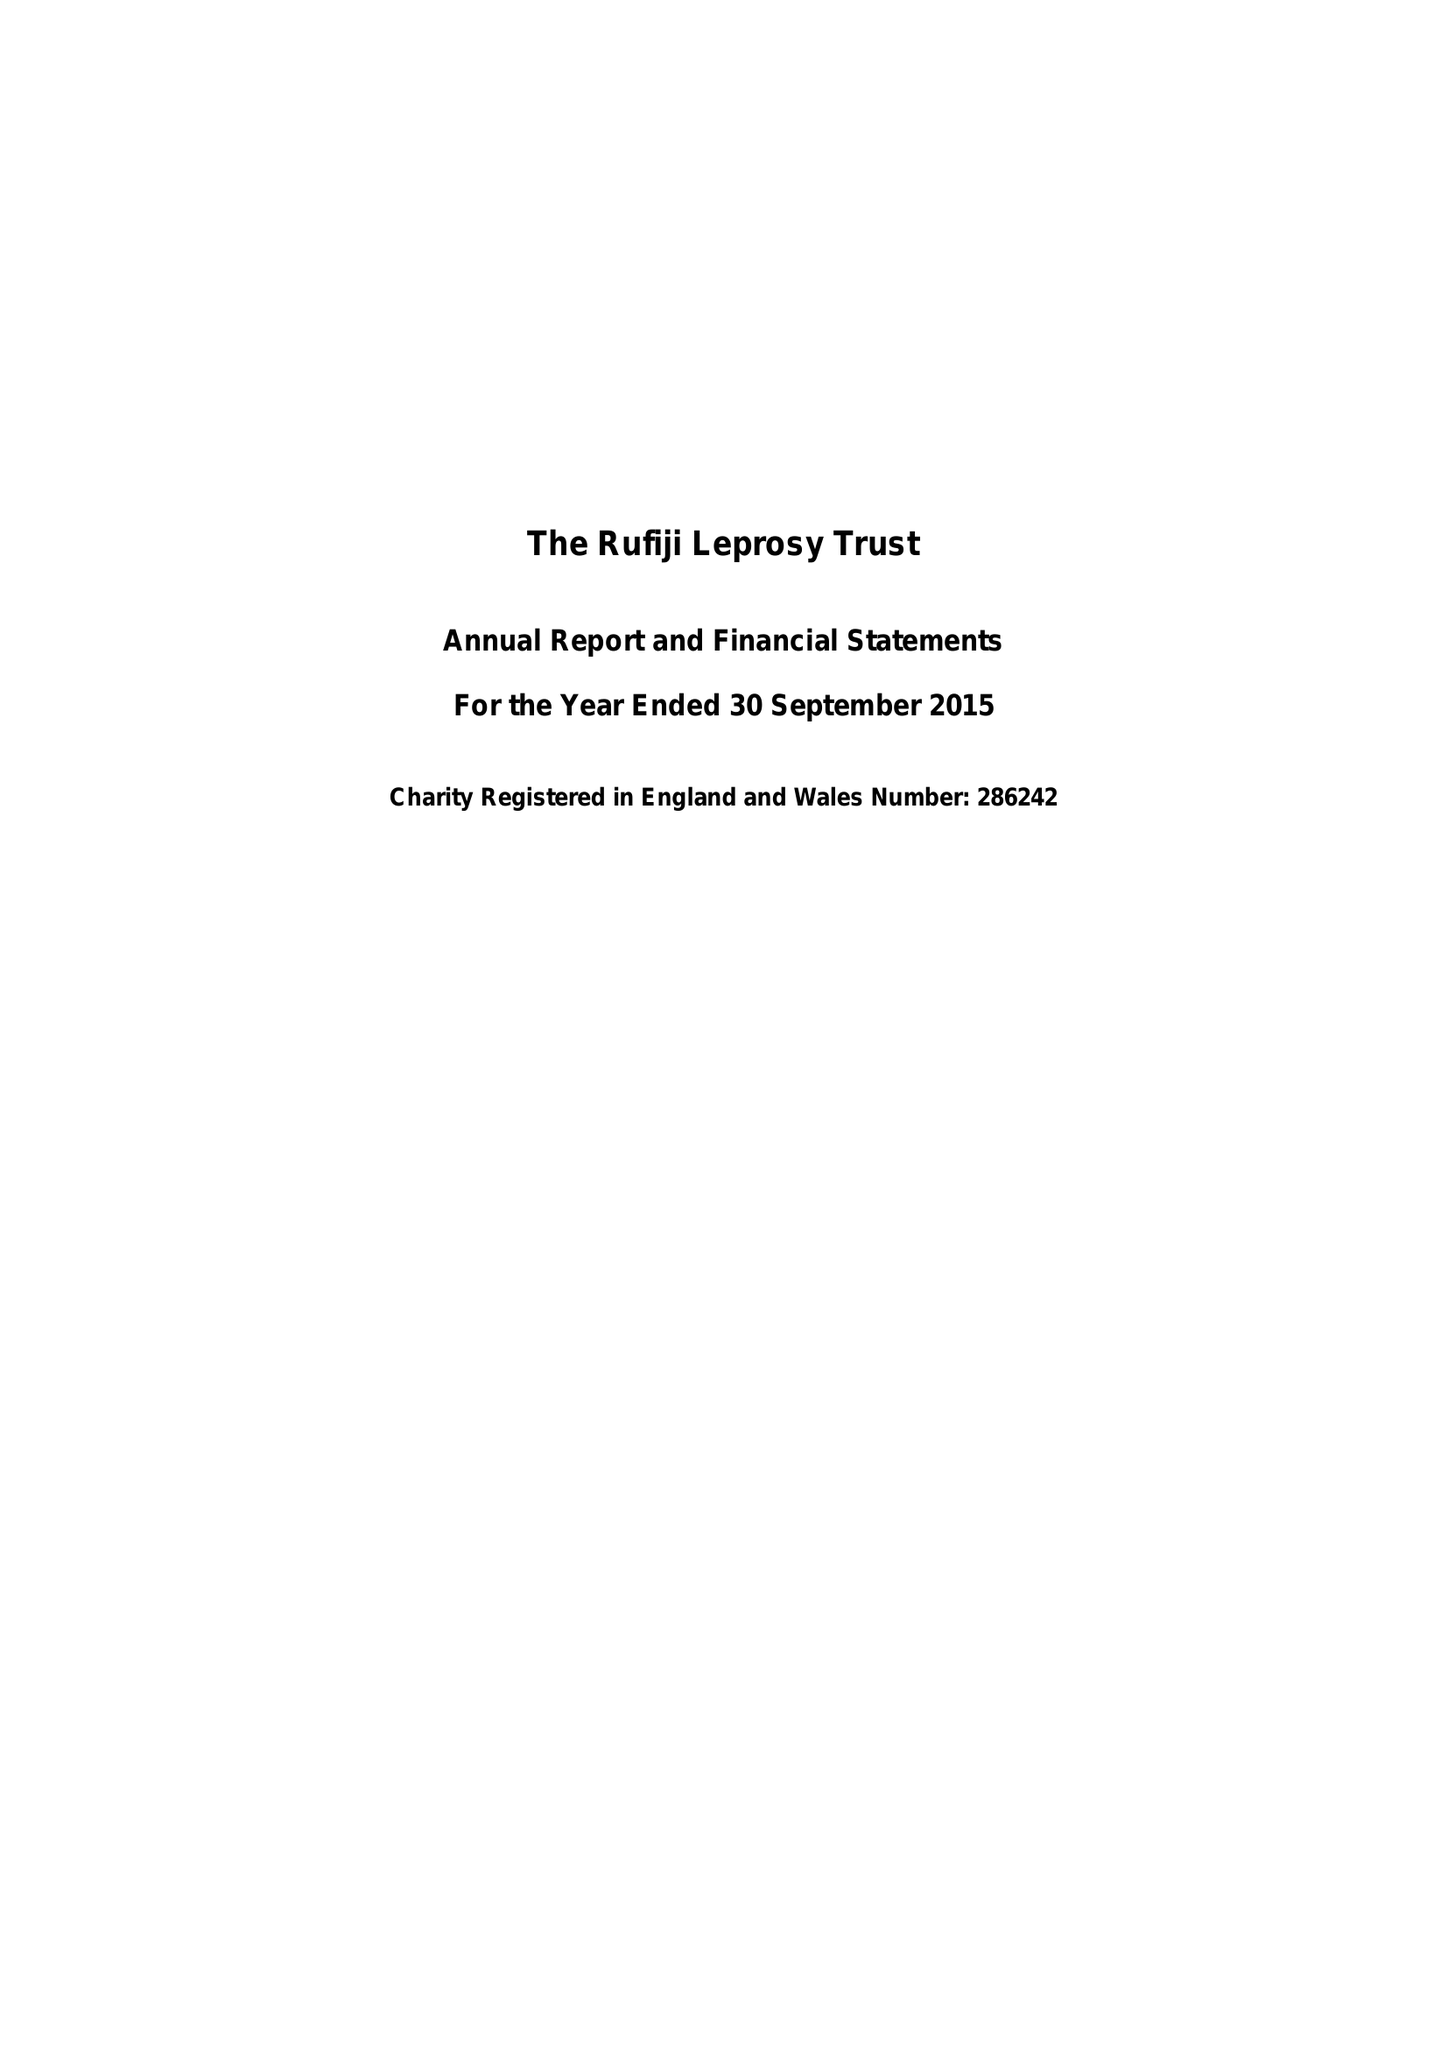What is the value for the charity_name?
Answer the question using a single word or phrase. The Rufiji Leprosy Trust 